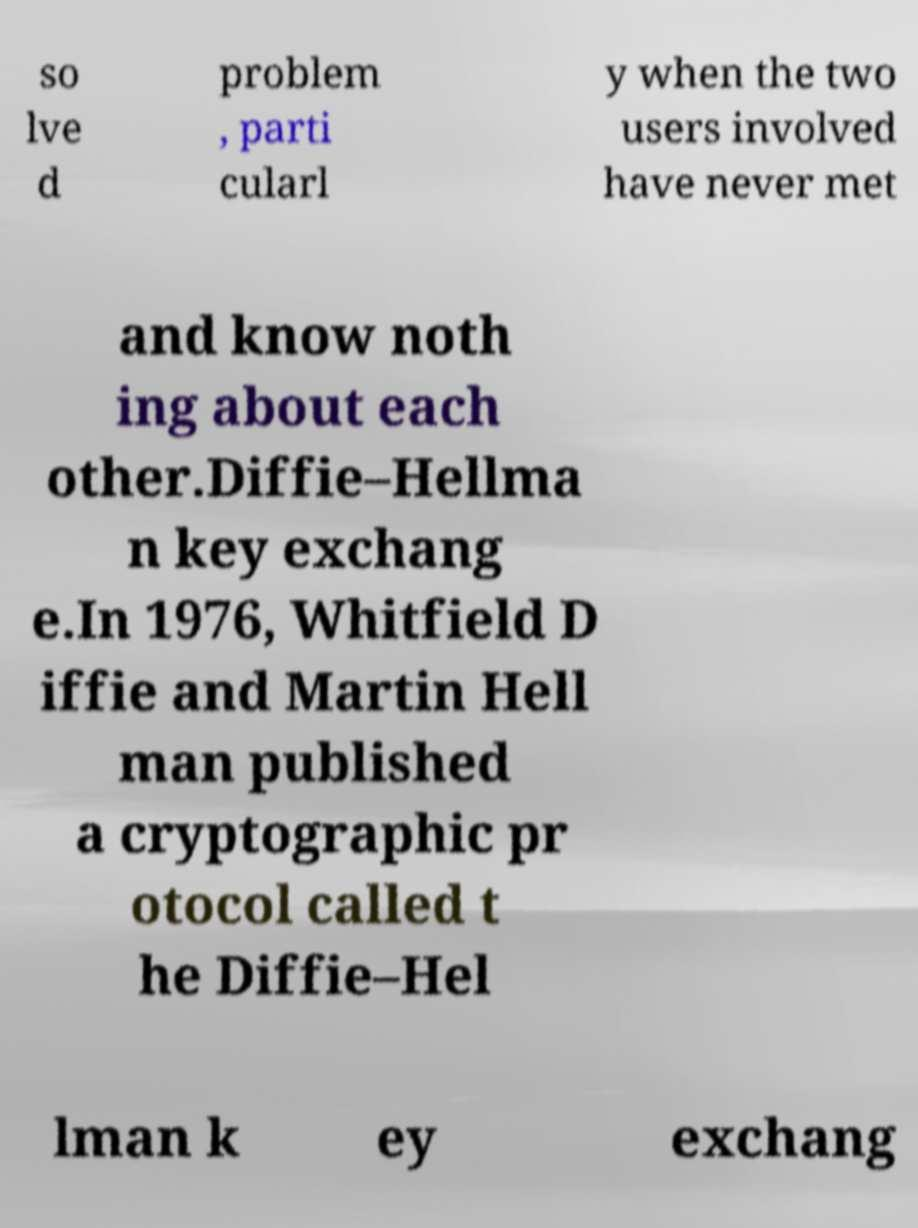Could you extract and type out the text from this image? so lve d problem , parti cularl y when the two users involved have never met and know noth ing about each other.Diffie–Hellma n key exchang e.In 1976, Whitfield D iffie and Martin Hell man published a cryptographic pr otocol called t he Diffie–Hel lman k ey exchang 